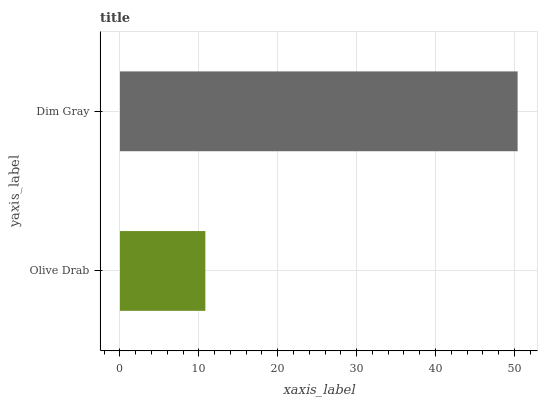Is Olive Drab the minimum?
Answer yes or no. Yes. Is Dim Gray the maximum?
Answer yes or no. Yes. Is Dim Gray the minimum?
Answer yes or no. No. Is Dim Gray greater than Olive Drab?
Answer yes or no. Yes. Is Olive Drab less than Dim Gray?
Answer yes or no. Yes. Is Olive Drab greater than Dim Gray?
Answer yes or no. No. Is Dim Gray less than Olive Drab?
Answer yes or no. No. Is Dim Gray the high median?
Answer yes or no. Yes. Is Olive Drab the low median?
Answer yes or no. Yes. Is Olive Drab the high median?
Answer yes or no. No. Is Dim Gray the low median?
Answer yes or no. No. 